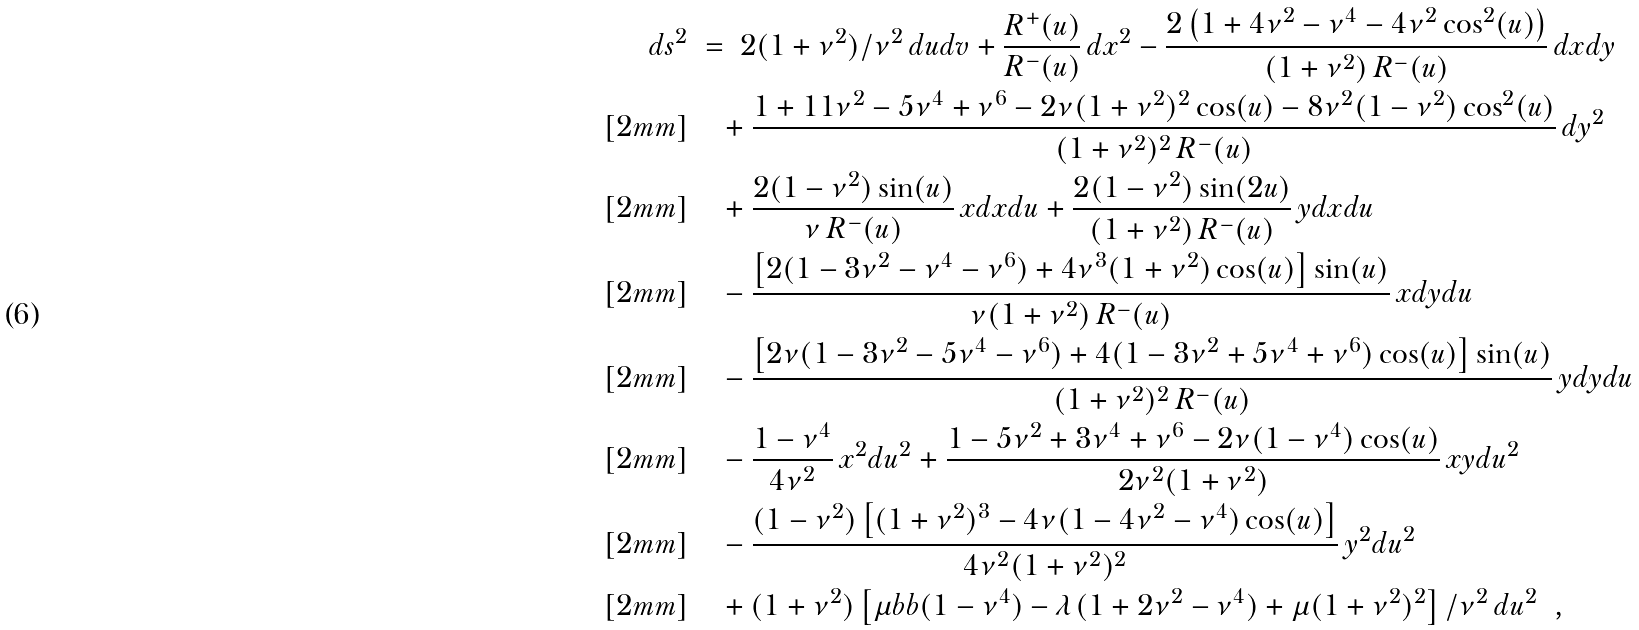<formula> <loc_0><loc_0><loc_500><loc_500>d s ^ { 2 } & \ = \ 2 ( 1 + \nu ^ { 2 } ) / \nu ^ { 2 } \, d u d v + \frac { R ^ { + } ( u ) } { R ^ { - } ( u ) } \, d x ^ { 2 } - \frac { 2 \left ( 1 + 4 \nu ^ { 2 } - \nu ^ { 4 } - 4 \nu ^ { 2 } \cos ^ { 2 } ( u ) \right ) } { ( 1 + \nu ^ { 2 } ) \, R ^ { - } ( u ) } \, d x d y \\ [ 2 m m ] & \quad + \frac { 1 + 1 1 \nu ^ { 2 } - 5 \nu ^ { 4 } + \nu ^ { 6 } - 2 \nu ( 1 + \nu ^ { 2 } ) ^ { 2 } \cos ( u ) - 8 \nu ^ { 2 } ( 1 - \nu ^ { 2 } ) \cos ^ { 2 } ( u ) } { ( 1 + \nu ^ { 2 } ) ^ { 2 } \, R ^ { - } ( u ) } \, d y ^ { 2 } \\ [ 2 m m ] & \quad + \frac { 2 ( 1 - \nu ^ { 2 } ) \sin ( u ) } { \nu \, R ^ { - } ( u ) } \, x d x d u + \frac { 2 ( 1 - \nu ^ { 2 } ) \sin ( 2 u ) } { ( 1 + \nu ^ { 2 } ) \, R ^ { - } ( u ) } \, y d x d u \\ [ 2 m m ] & \quad - \frac { \left [ 2 ( 1 - 3 \nu ^ { 2 } - \nu ^ { 4 } - \nu ^ { 6 } ) + 4 \nu ^ { 3 } ( 1 + \nu ^ { 2 } ) \cos ( u ) \right ] \sin ( u ) } { \nu ( 1 + \nu ^ { 2 } ) \, R ^ { - } ( u ) } \, x d y d u \\ [ 2 m m ] & \quad - \frac { \left [ 2 \nu ( 1 - 3 \nu ^ { 2 } - 5 \nu ^ { 4 } - \nu ^ { 6 } ) + 4 ( 1 - 3 \nu ^ { 2 } + 5 \nu ^ { 4 } + \nu ^ { 6 } ) \cos ( u ) \right ] \sin ( u ) } { ( 1 + \nu ^ { 2 } ) ^ { 2 } \, R ^ { - } ( u ) } \, y d y d u \\ [ 2 m m ] & \quad - \frac { 1 - \nu ^ { 4 } } { 4 \nu ^ { 2 } } \, x ^ { 2 } d u ^ { 2 } + \frac { 1 - 5 \nu ^ { 2 } + 3 \nu ^ { 4 } + \nu ^ { 6 } - 2 \nu ( 1 - \nu ^ { 4 } ) \cos ( u ) } { 2 \nu ^ { 2 } ( 1 + \nu ^ { 2 } ) } \, x y d u ^ { 2 } \\ [ 2 m m ] & \quad - \frac { ( 1 - \nu ^ { 2 } ) \left [ ( 1 + \nu ^ { 2 } ) ^ { 3 } - 4 \nu ( 1 - 4 \nu ^ { 2 } - \nu ^ { 4 } ) \cos ( u ) \right ] } { 4 \nu ^ { 2 } ( 1 + \nu ^ { 2 } ) ^ { 2 } } \, y ^ { 2 } d u ^ { 2 } \\ [ 2 m m ] & \quad + ( 1 + \nu ^ { 2 } ) \left [ \mu b b ( 1 - \nu ^ { 4 } ) - \lambda ( 1 + 2 \nu ^ { 2 } - \nu ^ { 4 } ) + \mu ( 1 + \nu ^ { 2 } ) ^ { 2 } \right ] / \nu ^ { 2 } \, d u ^ { 2 } \ \ ,</formula> 